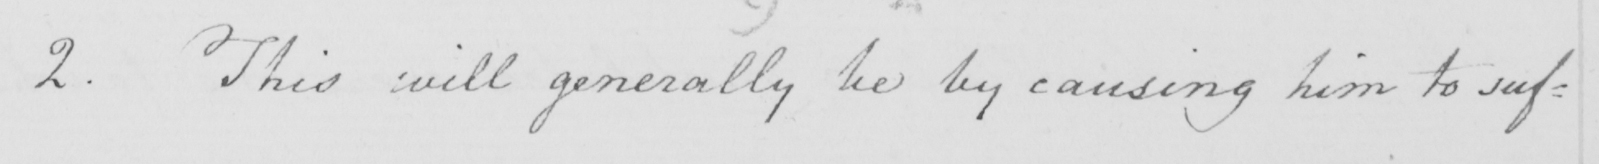What does this handwritten line say? 2 . This will generally be by causing him to suf= 